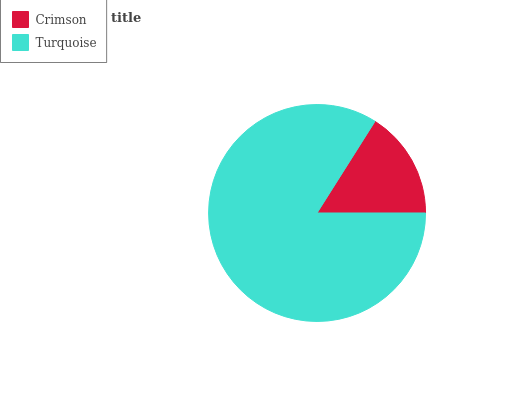Is Crimson the minimum?
Answer yes or no. Yes. Is Turquoise the maximum?
Answer yes or no. Yes. Is Turquoise the minimum?
Answer yes or no. No. Is Turquoise greater than Crimson?
Answer yes or no. Yes. Is Crimson less than Turquoise?
Answer yes or no. Yes. Is Crimson greater than Turquoise?
Answer yes or no. No. Is Turquoise less than Crimson?
Answer yes or no. No. Is Turquoise the high median?
Answer yes or no. Yes. Is Crimson the low median?
Answer yes or no. Yes. Is Crimson the high median?
Answer yes or no. No. Is Turquoise the low median?
Answer yes or no. No. 